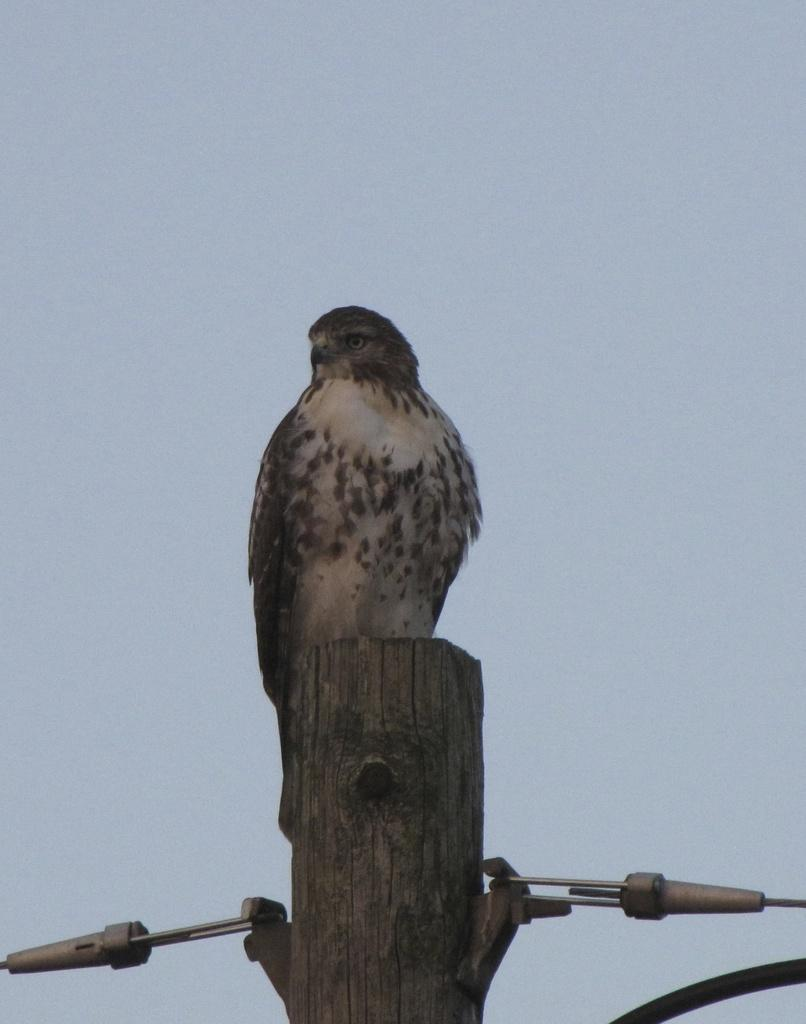What type of animal can be seen in the image? There is a bird in the image. Where is the bird located? The bird is on a tree branch. What else can be seen on the tree? There are objects on the tree. What is visible at the top of the image? The sky is visible at the top of the image. What type of minister is washing clothes in the image? There is no minister or washing of clothes present in the image; it features a bird on a tree branch. What type of school can be seen in the image? There is no school present in the image; it features a bird on a tree branch. 